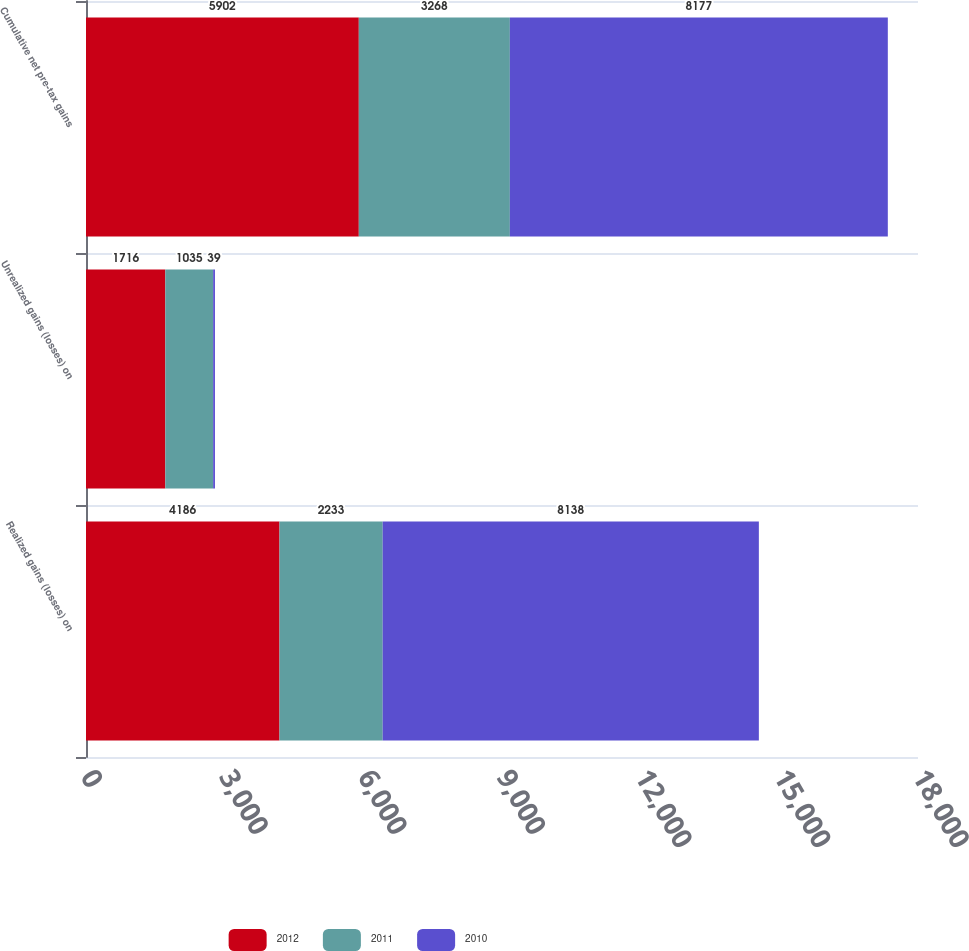Convert chart to OTSL. <chart><loc_0><loc_0><loc_500><loc_500><stacked_bar_chart><ecel><fcel>Realized gains (losses) on<fcel>Unrealized gains (losses) on<fcel>Cumulative net pre-tax gains<nl><fcel>2012<fcel>4186<fcel>1716<fcel>5902<nl><fcel>2011<fcel>2233<fcel>1035<fcel>3268<nl><fcel>2010<fcel>8138<fcel>39<fcel>8177<nl></chart> 